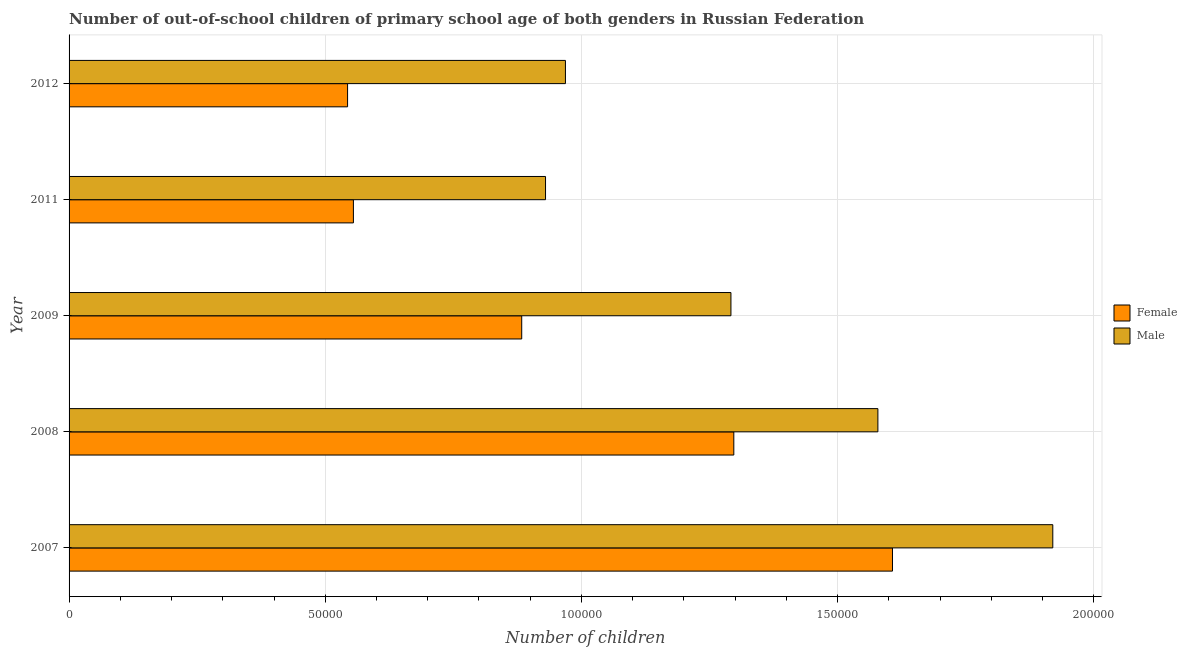How many groups of bars are there?
Provide a succinct answer. 5. Are the number of bars on each tick of the Y-axis equal?
Your answer should be compact. Yes. How many bars are there on the 4th tick from the top?
Offer a very short reply. 2. How many bars are there on the 2nd tick from the bottom?
Your answer should be very brief. 2. What is the label of the 3rd group of bars from the top?
Your answer should be compact. 2009. In how many cases, is the number of bars for a given year not equal to the number of legend labels?
Your response must be concise. 0. What is the number of male out-of-school students in 2007?
Give a very brief answer. 1.92e+05. Across all years, what is the maximum number of female out-of-school students?
Keep it short and to the point. 1.61e+05. Across all years, what is the minimum number of female out-of-school students?
Your answer should be compact. 5.44e+04. What is the total number of male out-of-school students in the graph?
Provide a succinct answer. 6.69e+05. What is the difference between the number of female out-of-school students in 2009 and that in 2012?
Provide a succinct answer. 3.40e+04. What is the difference between the number of female out-of-school students in 2008 and the number of male out-of-school students in 2007?
Provide a short and direct response. -6.23e+04. What is the average number of female out-of-school students per year?
Provide a succinct answer. 9.77e+04. In the year 2011, what is the difference between the number of female out-of-school students and number of male out-of-school students?
Provide a short and direct response. -3.75e+04. In how many years, is the number of male out-of-school students greater than 120000 ?
Your answer should be very brief. 3. What is the ratio of the number of male out-of-school students in 2008 to that in 2012?
Make the answer very short. 1.63. What is the difference between the highest and the second highest number of male out-of-school students?
Offer a very short reply. 3.41e+04. What is the difference between the highest and the lowest number of female out-of-school students?
Your response must be concise. 1.06e+05. In how many years, is the number of male out-of-school students greater than the average number of male out-of-school students taken over all years?
Provide a short and direct response. 2. Is the sum of the number of male out-of-school students in 2007 and 2012 greater than the maximum number of female out-of-school students across all years?
Keep it short and to the point. Yes. What does the 2nd bar from the top in 2007 represents?
Ensure brevity in your answer.  Female. What does the 1st bar from the bottom in 2007 represents?
Provide a short and direct response. Female. How many bars are there?
Provide a succinct answer. 10. Are all the bars in the graph horizontal?
Provide a short and direct response. Yes. How many years are there in the graph?
Provide a short and direct response. 5. Does the graph contain any zero values?
Provide a short and direct response. No. How many legend labels are there?
Ensure brevity in your answer.  2. What is the title of the graph?
Offer a very short reply. Number of out-of-school children of primary school age of both genders in Russian Federation. What is the label or title of the X-axis?
Offer a terse response. Number of children. What is the label or title of the Y-axis?
Provide a succinct answer. Year. What is the Number of children in Female in 2007?
Your answer should be compact. 1.61e+05. What is the Number of children in Male in 2007?
Your response must be concise. 1.92e+05. What is the Number of children in Female in 2008?
Offer a very short reply. 1.30e+05. What is the Number of children in Male in 2008?
Offer a very short reply. 1.58e+05. What is the Number of children in Female in 2009?
Your response must be concise. 8.84e+04. What is the Number of children of Male in 2009?
Keep it short and to the point. 1.29e+05. What is the Number of children in Female in 2011?
Your response must be concise. 5.55e+04. What is the Number of children of Male in 2011?
Keep it short and to the point. 9.30e+04. What is the Number of children of Female in 2012?
Provide a succinct answer. 5.44e+04. What is the Number of children of Male in 2012?
Keep it short and to the point. 9.69e+04. Across all years, what is the maximum Number of children in Female?
Make the answer very short. 1.61e+05. Across all years, what is the maximum Number of children in Male?
Make the answer very short. 1.92e+05. Across all years, what is the minimum Number of children in Female?
Ensure brevity in your answer.  5.44e+04. Across all years, what is the minimum Number of children in Male?
Offer a terse response. 9.30e+04. What is the total Number of children in Female in the graph?
Keep it short and to the point. 4.89e+05. What is the total Number of children in Male in the graph?
Offer a terse response. 6.69e+05. What is the difference between the Number of children of Female in 2007 and that in 2008?
Provide a succinct answer. 3.10e+04. What is the difference between the Number of children in Male in 2007 and that in 2008?
Ensure brevity in your answer.  3.41e+04. What is the difference between the Number of children of Female in 2007 and that in 2009?
Your answer should be very brief. 7.24e+04. What is the difference between the Number of children of Male in 2007 and that in 2009?
Ensure brevity in your answer.  6.28e+04. What is the difference between the Number of children in Female in 2007 and that in 2011?
Make the answer very short. 1.05e+05. What is the difference between the Number of children of Male in 2007 and that in 2011?
Ensure brevity in your answer.  9.90e+04. What is the difference between the Number of children of Female in 2007 and that in 2012?
Provide a succinct answer. 1.06e+05. What is the difference between the Number of children of Male in 2007 and that in 2012?
Keep it short and to the point. 9.51e+04. What is the difference between the Number of children of Female in 2008 and that in 2009?
Offer a terse response. 4.14e+04. What is the difference between the Number of children of Male in 2008 and that in 2009?
Ensure brevity in your answer.  2.87e+04. What is the difference between the Number of children in Female in 2008 and that in 2011?
Offer a terse response. 7.42e+04. What is the difference between the Number of children in Male in 2008 and that in 2011?
Offer a very short reply. 6.49e+04. What is the difference between the Number of children of Female in 2008 and that in 2012?
Keep it short and to the point. 7.54e+04. What is the difference between the Number of children in Male in 2008 and that in 2012?
Your answer should be very brief. 6.10e+04. What is the difference between the Number of children in Female in 2009 and that in 2011?
Provide a short and direct response. 3.29e+04. What is the difference between the Number of children of Male in 2009 and that in 2011?
Offer a terse response. 3.62e+04. What is the difference between the Number of children in Female in 2009 and that in 2012?
Offer a terse response. 3.40e+04. What is the difference between the Number of children in Male in 2009 and that in 2012?
Give a very brief answer. 3.23e+04. What is the difference between the Number of children in Female in 2011 and that in 2012?
Your answer should be very brief. 1138. What is the difference between the Number of children in Male in 2011 and that in 2012?
Your response must be concise. -3887. What is the difference between the Number of children of Female in 2007 and the Number of children of Male in 2008?
Your answer should be compact. 2849. What is the difference between the Number of children in Female in 2007 and the Number of children in Male in 2009?
Ensure brevity in your answer.  3.15e+04. What is the difference between the Number of children of Female in 2007 and the Number of children of Male in 2011?
Keep it short and to the point. 6.77e+04. What is the difference between the Number of children of Female in 2007 and the Number of children of Male in 2012?
Ensure brevity in your answer.  6.38e+04. What is the difference between the Number of children in Female in 2008 and the Number of children in Male in 2009?
Offer a terse response. 559. What is the difference between the Number of children of Female in 2008 and the Number of children of Male in 2011?
Your answer should be very brief. 3.68e+04. What is the difference between the Number of children in Female in 2008 and the Number of children in Male in 2012?
Make the answer very short. 3.29e+04. What is the difference between the Number of children in Female in 2009 and the Number of children in Male in 2011?
Offer a very short reply. -4646. What is the difference between the Number of children of Female in 2009 and the Number of children of Male in 2012?
Make the answer very short. -8533. What is the difference between the Number of children of Female in 2011 and the Number of children of Male in 2012?
Provide a short and direct response. -4.14e+04. What is the average Number of children of Female per year?
Make the answer very short. 9.77e+04. What is the average Number of children of Male per year?
Offer a terse response. 1.34e+05. In the year 2007, what is the difference between the Number of children in Female and Number of children in Male?
Keep it short and to the point. -3.13e+04. In the year 2008, what is the difference between the Number of children of Female and Number of children of Male?
Your answer should be very brief. -2.81e+04. In the year 2009, what is the difference between the Number of children of Female and Number of children of Male?
Your answer should be compact. -4.08e+04. In the year 2011, what is the difference between the Number of children in Female and Number of children in Male?
Provide a succinct answer. -3.75e+04. In the year 2012, what is the difference between the Number of children of Female and Number of children of Male?
Offer a very short reply. -4.25e+04. What is the ratio of the Number of children of Female in 2007 to that in 2008?
Your response must be concise. 1.24. What is the ratio of the Number of children of Male in 2007 to that in 2008?
Your answer should be compact. 1.22. What is the ratio of the Number of children of Female in 2007 to that in 2009?
Keep it short and to the point. 1.82. What is the ratio of the Number of children in Male in 2007 to that in 2009?
Keep it short and to the point. 1.49. What is the ratio of the Number of children of Female in 2007 to that in 2011?
Ensure brevity in your answer.  2.9. What is the ratio of the Number of children in Male in 2007 to that in 2011?
Ensure brevity in your answer.  2.06. What is the ratio of the Number of children in Female in 2007 to that in 2012?
Offer a terse response. 2.96. What is the ratio of the Number of children of Male in 2007 to that in 2012?
Keep it short and to the point. 1.98. What is the ratio of the Number of children of Female in 2008 to that in 2009?
Your response must be concise. 1.47. What is the ratio of the Number of children in Male in 2008 to that in 2009?
Your response must be concise. 1.22. What is the ratio of the Number of children in Female in 2008 to that in 2011?
Make the answer very short. 2.34. What is the ratio of the Number of children of Male in 2008 to that in 2011?
Give a very brief answer. 1.7. What is the ratio of the Number of children of Female in 2008 to that in 2012?
Your answer should be compact. 2.39. What is the ratio of the Number of children in Male in 2008 to that in 2012?
Keep it short and to the point. 1.63. What is the ratio of the Number of children of Female in 2009 to that in 2011?
Offer a terse response. 1.59. What is the ratio of the Number of children of Male in 2009 to that in 2011?
Give a very brief answer. 1.39. What is the ratio of the Number of children in Female in 2009 to that in 2012?
Give a very brief answer. 1.63. What is the ratio of the Number of children in Male in 2009 to that in 2012?
Offer a very short reply. 1.33. What is the ratio of the Number of children in Female in 2011 to that in 2012?
Offer a terse response. 1.02. What is the ratio of the Number of children in Male in 2011 to that in 2012?
Your answer should be very brief. 0.96. What is the difference between the highest and the second highest Number of children in Female?
Your answer should be very brief. 3.10e+04. What is the difference between the highest and the second highest Number of children of Male?
Your answer should be compact. 3.41e+04. What is the difference between the highest and the lowest Number of children in Female?
Offer a very short reply. 1.06e+05. What is the difference between the highest and the lowest Number of children of Male?
Provide a short and direct response. 9.90e+04. 